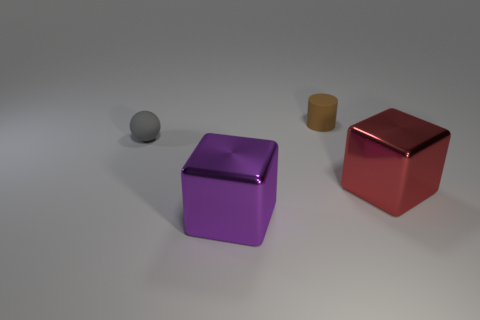Add 4 spheres. How many objects exist? 8 Subtract all red cubes. How many cubes are left? 1 Subtract all blue cubes. Subtract all red cylinders. How many cubes are left? 2 Subtract all gray cylinders. How many green cubes are left? 0 Subtract all large red metal cubes. Subtract all brown rubber objects. How many objects are left? 2 Add 4 balls. How many balls are left? 5 Add 3 small brown matte things. How many small brown matte things exist? 4 Subtract 0 brown cubes. How many objects are left? 4 